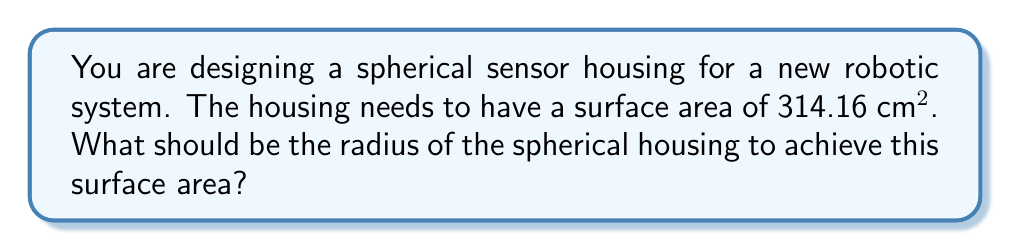Can you solve this math problem? Let's approach this step-by-step:

1) The formula for the surface area of a sphere is:
   $$A = 4\pi r^2$$
   Where $A$ is the surface area and $r$ is the radius.

2) We're given that the surface area $A = 314.16$ cm².

3) Let's substitute this into our formula:
   $$314.16 = 4\pi r^2$$

4) Now, let's solve for $r$:
   
   Divide both sides by $4\pi$:
   $$\frac{314.16}{4\pi} = r^2$$

5) Simplify:
   $$25 = r^2$$

6) Take the square root of both sides:
   $$\sqrt{25} = r$$

7) Simplify:
   $$5 = r$$

Therefore, the radius of the spherical housing should be 5 cm.
Answer: $5$ cm 